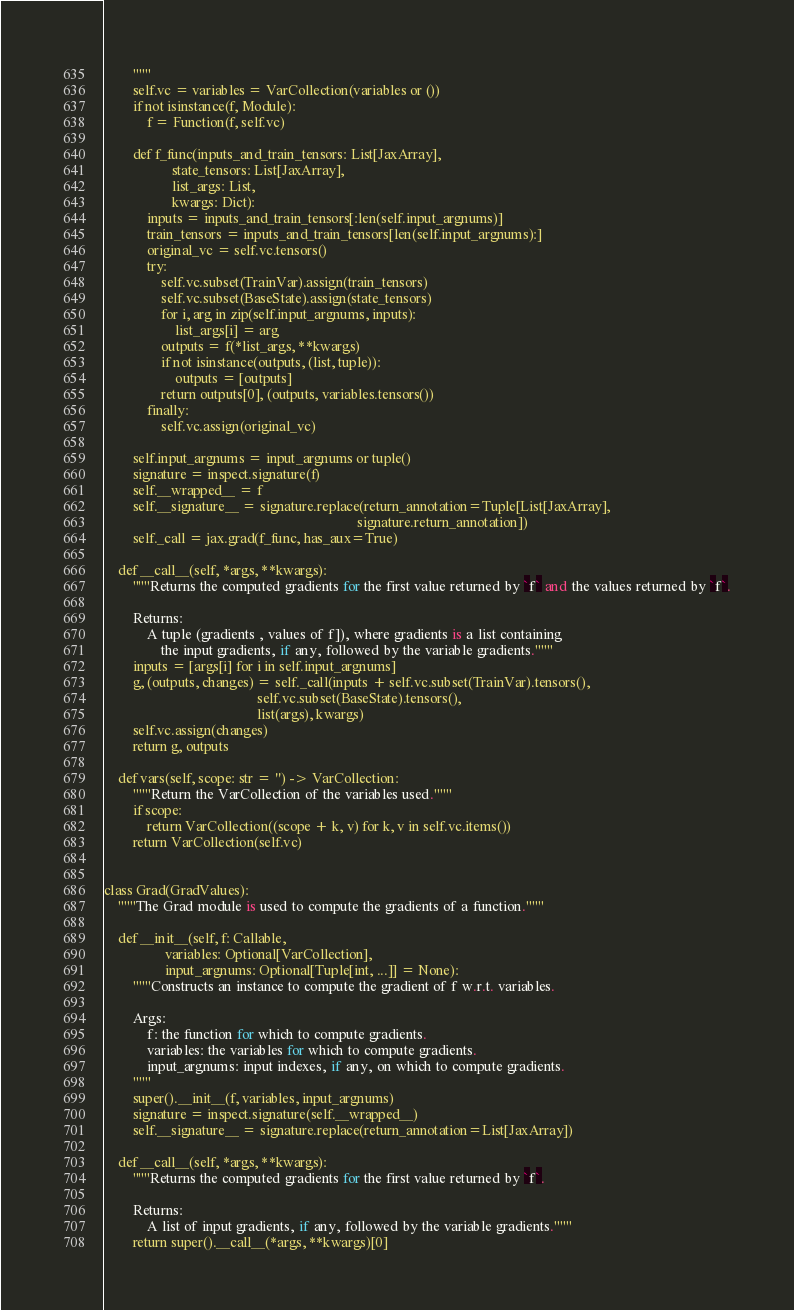Convert code to text. <code><loc_0><loc_0><loc_500><loc_500><_Python_>        """
        self.vc = variables = VarCollection(variables or ())
        if not isinstance(f, Module):
            f = Function(f, self.vc)

        def f_func(inputs_and_train_tensors: List[JaxArray],
                   state_tensors: List[JaxArray],
                   list_args: List,
                   kwargs: Dict):
            inputs = inputs_and_train_tensors[:len(self.input_argnums)]
            train_tensors = inputs_and_train_tensors[len(self.input_argnums):]
            original_vc = self.vc.tensors()
            try:
                self.vc.subset(TrainVar).assign(train_tensors)
                self.vc.subset(BaseState).assign(state_tensors)
                for i, arg in zip(self.input_argnums, inputs):
                    list_args[i] = arg
                outputs = f(*list_args, **kwargs)
                if not isinstance(outputs, (list, tuple)):
                    outputs = [outputs]
                return outputs[0], (outputs, variables.tensors())
            finally:
                self.vc.assign(original_vc)

        self.input_argnums = input_argnums or tuple()
        signature = inspect.signature(f)
        self.__wrapped__ = f
        self.__signature__ = signature.replace(return_annotation=Tuple[List[JaxArray],
                                                                       signature.return_annotation])
        self._call = jax.grad(f_func, has_aux=True)

    def __call__(self, *args, **kwargs):
        """Returns the computed gradients for the first value returned by `f` and the values returned by `f`.

        Returns:
            A tuple (gradients , values of f]), where gradients is a list containing
                the input gradients, if any, followed by the variable gradients."""
        inputs = [args[i] for i in self.input_argnums]
        g, (outputs, changes) = self._call(inputs + self.vc.subset(TrainVar).tensors(),
                                           self.vc.subset(BaseState).tensors(),
                                           list(args), kwargs)
        self.vc.assign(changes)
        return g, outputs

    def vars(self, scope: str = '') -> VarCollection:
        """Return the VarCollection of the variables used."""
        if scope:
            return VarCollection((scope + k, v) for k, v in self.vc.items())
        return VarCollection(self.vc)


class Grad(GradValues):
    """The Grad module is used to compute the gradients of a function."""

    def __init__(self, f: Callable,
                 variables: Optional[VarCollection],
                 input_argnums: Optional[Tuple[int, ...]] = None):
        """Constructs an instance to compute the gradient of f w.r.t. variables.

        Args:
            f: the function for which to compute gradients.
            variables: the variables for which to compute gradients.
            input_argnums: input indexes, if any, on which to compute gradients.
        """
        super().__init__(f, variables, input_argnums)
        signature = inspect.signature(self.__wrapped__)
        self.__signature__ = signature.replace(return_annotation=List[JaxArray])

    def __call__(self, *args, **kwargs):
        """Returns the computed gradients for the first value returned by `f`.

        Returns:
            A list of input gradients, if any, followed by the variable gradients."""
        return super().__call__(*args, **kwargs)[0]
</code> 